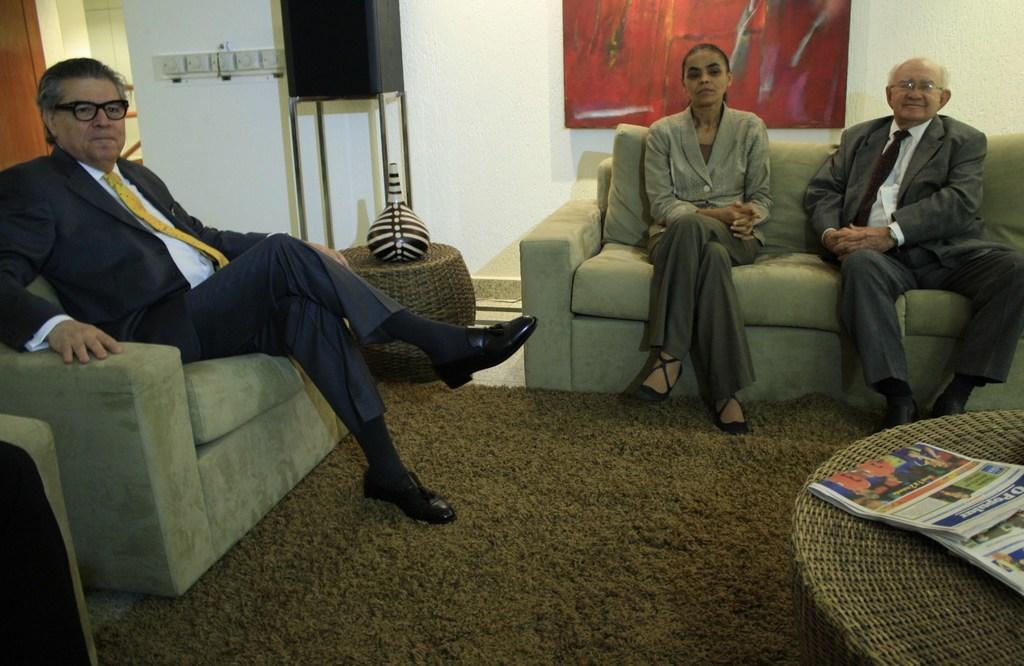In one or two sentences, can you explain what this image depicts? In this image we can see there are persons sitting on the couch. There is a mat on the floor. And there are chairs, on the chair there is a paper. At the back there is a stand with cloth and there is a wall, to the wall there is a board with painting. 